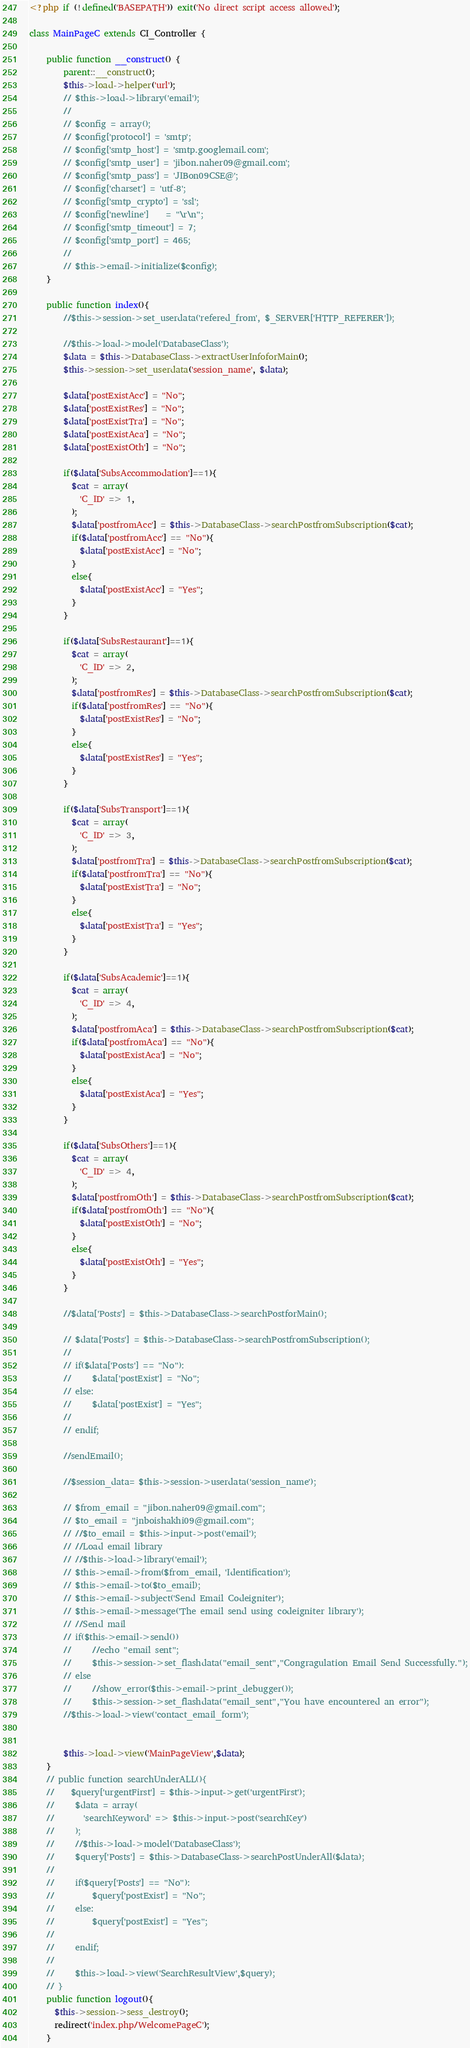Convert code to text. <code><loc_0><loc_0><loc_500><loc_500><_PHP_><?php if (!defined('BASEPATH')) exit('No direct script access allowed');

class MainPageC extends CI_Controller {

    public function __construct() {
        parent::__construct();
        $this->load->helper('url');
        // $this->load->library('email');
        //
        // $config = array();
        // $config['protocol'] = 'smtp';
        // $config['smtp_host'] = 'smtp.googlemail.com';
        // $config['smtp_user'] = 'jibon.naher09@gmail.com';
        // $config['smtp_pass'] = 'JIBon09CSE@';
        // $config['charset'] = 'utf-8';
        // $config['smtp_crypto'] = 'ssl';
        // $config['newline']    = "\r\n";
        // $config['smtp_timeout'] = 7;
        // $config['smtp_port'] = 465;
        //
        // $this->email->initialize($config);
    }

    public function index(){
        //$this->session->set_userdata('refered_from', $_SERVER['HTTP_REFERER']);

        //$this->load->model('DatabaseClass');
        $data = $this->DatabaseClass->extractUserInfoforMain();
        $this->session->set_userdata('session_name', $data);

        $data['postExistAcc'] = "No";
        $data['postExistRes'] = "No";
        $data['postExistTra'] = "No";
        $data['postExistAca'] = "No";
        $data['postExistOth'] = "No";

        if($data['SubsAccommodation']==1){
          $cat = array(
            'C_ID' => 1,
          );
          $data['postfromAcc'] = $this->DatabaseClass->searchPostfromSubscription($cat);
          if($data['postfromAcc'] == "No"){
            $data['postExistAcc'] = "No";
          }
          else{
            $data['postExistAcc'] = "Yes";
          }
        }

        if($data['SubsRestaurant']==1){
          $cat = array(
            'C_ID' => 2,
          );
          $data['postfromRes'] = $this->DatabaseClass->searchPostfromSubscription($cat);
          if($data['postfromRes'] == "No"){
            $data['postExistRes'] = "No";
          }
          else{
            $data['postExistRes'] = "Yes";
          }
        }

        if($data['SubsTransport']==1){
          $cat = array(
            'C_ID' => 3,
          );
          $data['postfromTra'] = $this->DatabaseClass->searchPostfromSubscription($cat);
          if($data['postfromTra'] == "No"){
            $data['postExistTra'] = "No";
          }
          else{
            $data['postExistTra'] = "Yes";
          }
        }

        if($data['SubsAcademic']==1){
          $cat = array(
            'C_ID' => 4,
          );
          $data['postfromAca'] = $this->DatabaseClass->searchPostfromSubscription($cat);
          if($data['postfromAca'] == "No"){
            $data['postExistAca'] = "No";
          }
          else{
            $data['postExistAca'] = "Yes";
          }
        }

        if($data['SubsOthers']==1){
          $cat = array(
            'C_ID' => 4,
          );
          $data['postfromOth'] = $this->DatabaseClass->searchPostfromSubscription($cat);
          if($data['postfromOth'] == "No"){
            $data['postExistOth'] = "No";
          }
          else{
            $data['postExistOth'] = "Yes";
          }
        }

        //$data['Posts'] = $this->DatabaseClass->searchPostforMain();

        // $data['Posts'] = $this->DatabaseClass->searchPostfromSubscription();
        //
        // if($data['Posts'] == "No"):
        //     $data['postExist'] = "No";
        // else:
        //     $data['postExist'] = "Yes";
        //
        // endif;

        //sendEmail();

        //$session_data= $this->session->userdata('session_name');

        // $from_email = "jibon.naher09@gmail.com";
        // $to_email = "jnboishakhi09@gmail.com";
        // //$to_email = $this->input->post('email');
        // //Load email library
        // //$this->load->library('email');
        // $this->email->from($from_email, 'Identification');
        // $this->email->to($to_email);
        // $this->email->subject('Send Email Codeigniter');
        // $this->email->message('The email send using codeigniter library');
        // //Send mail
        // if($this->email->send())
        //     //echo "email sent";
        //     $this->session->set_flashdata("email_sent","Congragulation Email Send Successfully.");
        // else
        //     //show_error($this->email->print_debugger());
        //     $this->session->set_flashdata("email_sent","You have encountered an error");
        //$this->load->view('contact_email_form');


        $this->load->view('MainPageView',$data);
    }
    // public function searchUnderALL(){
    //    $query['urgentFirst'] = $this->input->get('urgentFirst');
    //     $data = array(
    //       'searchKeyword' => $this->input->post('searchKey')
    //     );
    //     //$this->load->model('DatabaseClass');
    //     $query['Posts'] = $this->DatabaseClass->searchPostUnderAll($data);
    //
    //     if($query['Posts'] == "No"):
    //         $query['postExist'] = "No";
    //     else:
    //         $query['postExist'] = "Yes";
    //
    //     endif;
    //
    //     $this->load->view('SearchResultView',$query);
    // }
    public function logout(){
      $this->session->sess_destroy();
      redirect('index.php/WelcomePageC');
    }</code> 